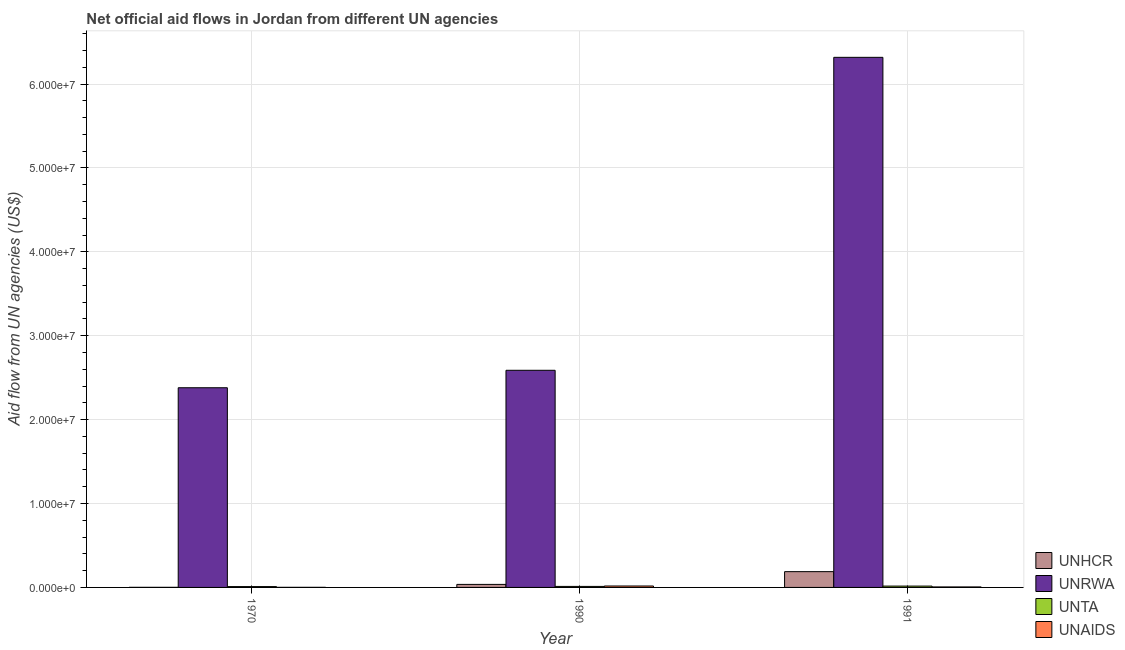How many groups of bars are there?
Keep it short and to the point. 3. Are the number of bars per tick equal to the number of legend labels?
Give a very brief answer. Yes. Are the number of bars on each tick of the X-axis equal?
Provide a succinct answer. Yes. What is the amount of aid given by unrwa in 1991?
Offer a very short reply. 6.32e+07. Across all years, what is the maximum amount of aid given by unrwa?
Ensure brevity in your answer.  6.32e+07. Across all years, what is the minimum amount of aid given by unta?
Make the answer very short. 1.00e+05. In which year was the amount of aid given by unaids maximum?
Your response must be concise. 1990. In which year was the amount of aid given by unrwa minimum?
Keep it short and to the point. 1970. What is the total amount of aid given by unta in the graph?
Your answer should be very brief. 3.80e+05. What is the difference between the amount of aid given by unrwa in 1970 and that in 1990?
Keep it short and to the point. -2.08e+06. What is the difference between the amount of aid given by unaids in 1991 and the amount of aid given by unrwa in 1990?
Your answer should be very brief. -1.10e+05. What is the average amount of aid given by unaids per year?
Keep it short and to the point. 8.00e+04. In the year 1990, what is the difference between the amount of aid given by unhcr and amount of aid given by unta?
Make the answer very short. 0. In how many years, is the amount of aid given by unhcr greater than 62000000 US$?
Keep it short and to the point. 0. What is the ratio of the amount of aid given by unhcr in 1970 to that in 1990?
Offer a terse response. 0.03. Is the difference between the amount of aid given by unta in 1970 and 1991 greater than the difference between the amount of aid given by unhcr in 1970 and 1991?
Your response must be concise. No. What is the difference between the highest and the lowest amount of aid given by unaids?
Make the answer very short. 1.60e+05. In how many years, is the amount of aid given by unta greater than the average amount of aid given by unta taken over all years?
Your answer should be very brief. 1. Is it the case that in every year, the sum of the amount of aid given by unta and amount of aid given by unhcr is greater than the sum of amount of aid given by unrwa and amount of aid given by unaids?
Ensure brevity in your answer.  No. What does the 3rd bar from the left in 1990 represents?
Your response must be concise. UNTA. What does the 2nd bar from the right in 1991 represents?
Make the answer very short. UNTA. Is it the case that in every year, the sum of the amount of aid given by unhcr and amount of aid given by unrwa is greater than the amount of aid given by unta?
Give a very brief answer. Yes. How many bars are there?
Ensure brevity in your answer.  12. Are all the bars in the graph horizontal?
Your answer should be very brief. No. Are the values on the major ticks of Y-axis written in scientific E-notation?
Your answer should be very brief. Yes. How many legend labels are there?
Your answer should be very brief. 4. How are the legend labels stacked?
Provide a short and direct response. Vertical. What is the title of the graph?
Make the answer very short. Net official aid flows in Jordan from different UN agencies. What is the label or title of the Y-axis?
Provide a short and direct response. Aid flow from UN agencies (US$). What is the Aid flow from UN agencies (US$) in UNRWA in 1970?
Offer a very short reply. 2.38e+07. What is the Aid flow from UN agencies (US$) of UNTA in 1970?
Your response must be concise. 1.00e+05. What is the Aid flow from UN agencies (US$) in UNAIDS in 1970?
Give a very brief answer. 10000. What is the Aid flow from UN agencies (US$) of UNRWA in 1990?
Ensure brevity in your answer.  2.59e+07. What is the Aid flow from UN agencies (US$) of UNHCR in 1991?
Your response must be concise. 1.88e+06. What is the Aid flow from UN agencies (US$) in UNRWA in 1991?
Offer a very short reply. 6.32e+07. What is the Aid flow from UN agencies (US$) in UNTA in 1991?
Your answer should be very brief. 1.60e+05. Across all years, what is the maximum Aid flow from UN agencies (US$) of UNHCR?
Give a very brief answer. 1.88e+06. Across all years, what is the maximum Aid flow from UN agencies (US$) of UNRWA?
Offer a terse response. 6.32e+07. Across all years, what is the maximum Aid flow from UN agencies (US$) in UNAIDS?
Make the answer very short. 1.70e+05. Across all years, what is the minimum Aid flow from UN agencies (US$) in UNRWA?
Your answer should be very brief. 2.38e+07. Across all years, what is the minimum Aid flow from UN agencies (US$) of UNTA?
Offer a very short reply. 1.00e+05. Across all years, what is the minimum Aid flow from UN agencies (US$) of UNAIDS?
Your answer should be compact. 10000. What is the total Aid flow from UN agencies (US$) in UNHCR in the graph?
Provide a short and direct response. 2.25e+06. What is the total Aid flow from UN agencies (US$) of UNRWA in the graph?
Offer a terse response. 1.13e+08. What is the total Aid flow from UN agencies (US$) in UNTA in the graph?
Provide a short and direct response. 3.80e+05. What is the total Aid flow from UN agencies (US$) in UNAIDS in the graph?
Provide a succinct answer. 2.40e+05. What is the difference between the Aid flow from UN agencies (US$) of UNHCR in 1970 and that in 1990?
Your response must be concise. -3.50e+05. What is the difference between the Aid flow from UN agencies (US$) in UNRWA in 1970 and that in 1990?
Make the answer very short. -2.08e+06. What is the difference between the Aid flow from UN agencies (US$) in UNAIDS in 1970 and that in 1990?
Provide a short and direct response. -1.60e+05. What is the difference between the Aid flow from UN agencies (US$) in UNHCR in 1970 and that in 1991?
Give a very brief answer. -1.87e+06. What is the difference between the Aid flow from UN agencies (US$) in UNRWA in 1970 and that in 1991?
Provide a succinct answer. -3.94e+07. What is the difference between the Aid flow from UN agencies (US$) in UNTA in 1970 and that in 1991?
Ensure brevity in your answer.  -6.00e+04. What is the difference between the Aid flow from UN agencies (US$) of UNHCR in 1990 and that in 1991?
Provide a succinct answer. -1.52e+06. What is the difference between the Aid flow from UN agencies (US$) in UNRWA in 1990 and that in 1991?
Offer a terse response. -3.73e+07. What is the difference between the Aid flow from UN agencies (US$) in UNTA in 1990 and that in 1991?
Ensure brevity in your answer.  -4.00e+04. What is the difference between the Aid flow from UN agencies (US$) of UNHCR in 1970 and the Aid flow from UN agencies (US$) of UNRWA in 1990?
Your answer should be compact. -2.59e+07. What is the difference between the Aid flow from UN agencies (US$) of UNHCR in 1970 and the Aid flow from UN agencies (US$) of UNTA in 1990?
Keep it short and to the point. -1.10e+05. What is the difference between the Aid flow from UN agencies (US$) in UNHCR in 1970 and the Aid flow from UN agencies (US$) in UNAIDS in 1990?
Keep it short and to the point. -1.60e+05. What is the difference between the Aid flow from UN agencies (US$) in UNRWA in 1970 and the Aid flow from UN agencies (US$) in UNTA in 1990?
Make the answer very short. 2.37e+07. What is the difference between the Aid flow from UN agencies (US$) in UNRWA in 1970 and the Aid flow from UN agencies (US$) in UNAIDS in 1990?
Your response must be concise. 2.36e+07. What is the difference between the Aid flow from UN agencies (US$) of UNHCR in 1970 and the Aid flow from UN agencies (US$) of UNRWA in 1991?
Offer a very short reply. -6.32e+07. What is the difference between the Aid flow from UN agencies (US$) in UNHCR in 1970 and the Aid flow from UN agencies (US$) in UNAIDS in 1991?
Keep it short and to the point. -5.00e+04. What is the difference between the Aid flow from UN agencies (US$) of UNRWA in 1970 and the Aid flow from UN agencies (US$) of UNTA in 1991?
Keep it short and to the point. 2.36e+07. What is the difference between the Aid flow from UN agencies (US$) in UNRWA in 1970 and the Aid flow from UN agencies (US$) in UNAIDS in 1991?
Your answer should be very brief. 2.37e+07. What is the difference between the Aid flow from UN agencies (US$) in UNTA in 1970 and the Aid flow from UN agencies (US$) in UNAIDS in 1991?
Make the answer very short. 4.00e+04. What is the difference between the Aid flow from UN agencies (US$) in UNHCR in 1990 and the Aid flow from UN agencies (US$) in UNRWA in 1991?
Keep it short and to the point. -6.28e+07. What is the difference between the Aid flow from UN agencies (US$) of UNHCR in 1990 and the Aid flow from UN agencies (US$) of UNAIDS in 1991?
Make the answer very short. 3.00e+05. What is the difference between the Aid flow from UN agencies (US$) of UNRWA in 1990 and the Aid flow from UN agencies (US$) of UNTA in 1991?
Your response must be concise. 2.57e+07. What is the difference between the Aid flow from UN agencies (US$) in UNRWA in 1990 and the Aid flow from UN agencies (US$) in UNAIDS in 1991?
Offer a very short reply. 2.58e+07. What is the average Aid flow from UN agencies (US$) of UNHCR per year?
Give a very brief answer. 7.50e+05. What is the average Aid flow from UN agencies (US$) of UNRWA per year?
Your response must be concise. 3.76e+07. What is the average Aid flow from UN agencies (US$) of UNTA per year?
Offer a terse response. 1.27e+05. What is the average Aid flow from UN agencies (US$) in UNAIDS per year?
Offer a terse response. 8.00e+04. In the year 1970, what is the difference between the Aid flow from UN agencies (US$) in UNHCR and Aid flow from UN agencies (US$) in UNRWA?
Your answer should be very brief. -2.38e+07. In the year 1970, what is the difference between the Aid flow from UN agencies (US$) in UNHCR and Aid flow from UN agencies (US$) in UNTA?
Your answer should be very brief. -9.00e+04. In the year 1970, what is the difference between the Aid flow from UN agencies (US$) in UNHCR and Aid flow from UN agencies (US$) in UNAIDS?
Ensure brevity in your answer.  0. In the year 1970, what is the difference between the Aid flow from UN agencies (US$) in UNRWA and Aid flow from UN agencies (US$) in UNTA?
Offer a very short reply. 2.37e+07. In the year 1970, what is the difference between the Aid flow from UN agencies (US$) in UNRWA and Aid flow from UN agencies (US$) in UNAIDS?
Offer a very short reply. 2.38e+07. In the year 1970, what is the difference between the Aid flow from UN agencies (US$) in UNTA and Aid flow from UN agencies (US$) in UNAIDS?
Your answer should be very brief. 9.00e+04. In the year 1990, what is the difference between the Aid flow from UN agencies (US$) in UNHCR and Aid flow from UN agencies (US$) in UNRWA?
Make the answer very short. -2.55e+07. In the year 1990, what is the difference between the Aid flow from UN agencies (US$) of UNHCR and Aid flow from UN agencies (US$) of UNTA?
Your answer should be very brief. 2.40e+05. In the year 1990, what is the difference between the Aid flow from UN agencies (US$) of UNHCR and Aid flow from UN agencies (US$) of UNAIDS?
Make the answer very short. 1.90e+05. In the year 1990, what is the difference between the Aid flow from UN agencies (US$) in UNRWA and Aid flow from UN agencies (US$) in UNTA?
Offer a terse response. 2.58e+07. In the year 1990, what is the difference between the Aid flow from UN agencies (US$) in UNRWA and Aid flow from UN agencies (US$) in UNAIDS?
Give a very brief answer. 2.57e+07. In the year 1990, what is the difference between the Aid flow from UN agencies (US$) in UNTA and Aid flow from UN agencies (US$) in UNAIDS?
Keep it short and to the point. -5.00e+04. In the year 1991, what is the difference between the Aid flow from UN agencies (US$) of UNHCR and Aid flow from UN agencies (US$) of UNRWA?
Provide a succinct answer. -6.13e+07. In the year 1991, what is the difference between the Aid flow from UN agencies (US$) of UNHCR and Aid flow from UN agencies (US$) of UNTA?
Provide a succinct answer. 1.72e+06. In the year 1991, what is the difference between the Aid flow from UN agencies (US$) in UNHCR and Aid flow from UN agencies (US$) in UNAIDS?
Give a very brief answer. 1.82e+06. In the year 1991, what is the difference between the Aid flow from UN agencies (US$) in UNRWA and Aid flow from UN agencies (US$) in UNTA?
Your response must be concise. 6.30e+07. In the year 1991, what is the difference between the Aid flow from UN agencies (US$) in UNRWA and Aid flow from UN agencies (US$) in UNAIDS?
Provide a succinct answer. 6.31e+07. In the year 1991, what is the difference between the Aid flow from UN agencies (US$) in UNTA and Aid flow from UN agencies (US$) in UNAIDS?
Provide a short and direct response. 1.00e+05. What is the ratio of the Aid flow from UN agencies (US$) in UNHCR in 1970 to that in 1990?
Your response must be concise. 0.03. What is the ratio of the Aid flow from UN agencies (US$) in UNRWA in 1970 to that in 1990?
Offer a very short reply. 0.92. What is the ratio of the Aid flow from UN agencies (US$) of UNAIDS in 1970 to that in 1990?
Your response must be concise. 0.06. What is the ratio of the Aid flow from UN agencies (US$) in UNHCR in 1970 to that in 1991?
Your answer should be very brief. 0.01. What is the ratio of the Aid flow from UN agencies (US$) of UNRWA in 1970 to that in 1991?
Provide a succinct answer. 0.38. What is the ratio of the Aid flow from UN agencies (US$) in UNTA in 1970 to that in 1991?
Keep it short and to the point. 0.62. What is the ratio of the Aid flow from UN agencies (US$) of UNHCR in 1990 to that in 1991?
Offer a very short reply. 0.19. What is the ratio of the Aid flow from UN agencies (US$) of UNRWA in 1990 to that in 1991?
Make the answer very short. 0.41. What is the ratio of the Aid flow from UN agencies (US$) in UNAIDS in 1990 to that in 1991?
Provide a short and direct response. 2.83. What is the difference between the highest and the second highest Aid flow from UN agencies (US$) in UNHCR?
Make the answer very short. 1.52e+06. What is the difference between the highest and the second highest Aid flow from UN agencies (US$) in UNRWA?
Ensure brevity in your answer.  3.73e+07. What is the difference between the highest and the second highest Aid flow from UN agencies (US$) of UNTA?
Ensure brevity in your answer.  4.00e+04. What is the difference between the highest and the lowest Aid flow from UN agencies (US$) in UNHCR?
Provide a short and direct response. 1.87e+06. What is the difference between the highest and the lowest Aid flow from UN agencies (US$) in UNRWA?
Your answer should be compact. 3.94e+07. 